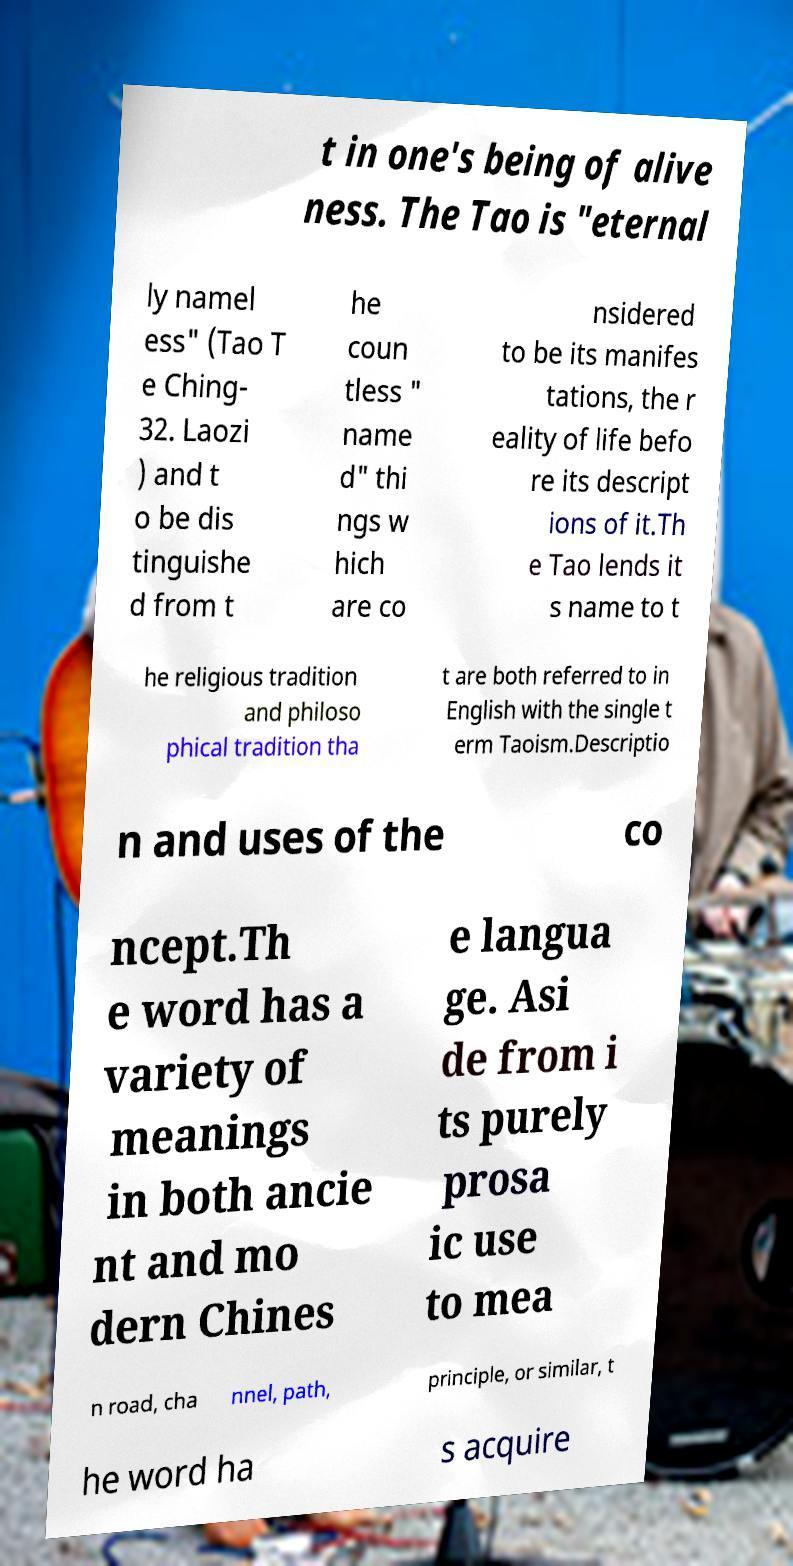Please read and relay the text visible in this image. What does it say? t in one's being of alive ness. The Tao is "eternal ly namel ess" (Tao T e Ching- 32. Laozi ) and t o be dis tinguishe d from t he coun tless " name d" thi ngs w hich are co nsidered to be its manifes tations, the r eality of life befo re its descript ions of it.Th e Tao lends it s name to t he religious tradition and philoso phical tradition tha t are both referred to in English with the single t erm Taoism.Descriptio n and uses of the co ncept.Th e word has a variety of meanings in both ancie nt and mo dern Chines e langua ge. Asi de from i ts purely prosa ic use to mea n road, cha nnel, path, principle, or similar, t he word ha s acquire 